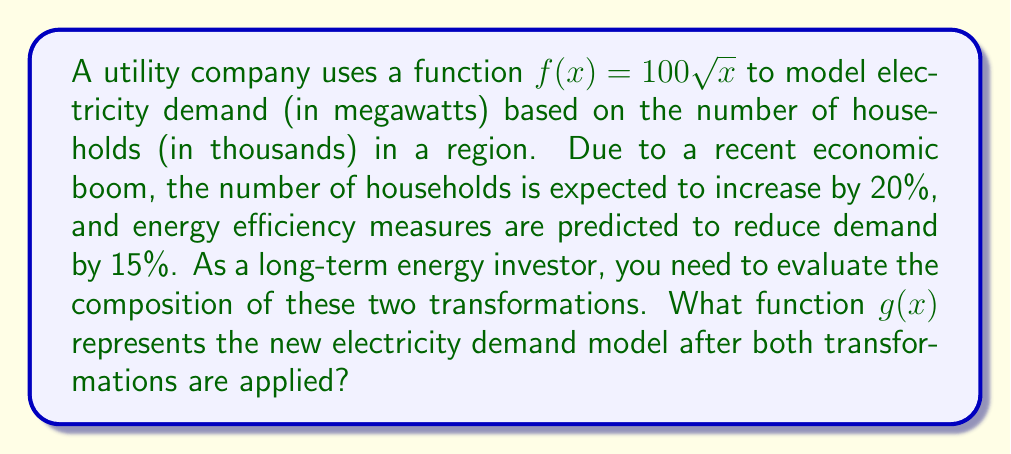Help me with this question. Let's approach this step-by-step:

1) First, we need to understand the two transformations:
   a) 20% increase in households: This is a horizontal compression by a factor of $\frac{1}{1.2}$
   b) 15% decrease in demand: This is a vertical compression by a factor of 0.85

2) Let's apply these transformations one at a time:

   a) For the horizontal compression:
      $f_1(x) = f(1.2x) = 100\sqrt{1.2x}$

   b) Now, for the vertical compression:
      $g(x) = 0.85f_1(x) = 0.85(100\sqrt{1.2x})$

3) Simplify:
   $g(x) = 85\sqrt{1.2x}$

4) We can further simplify by taking the constant under the square root:
   $g(x) = 85\sqrt{1.2}\sqrt{x}$

5) Calculate $\sqrt{1.2}$:
   $\sqrt{1.2} \approx 1.0954$

6) Therefore, our final function is:
   $g(x) = 85(1.0954)\sqrt{x} \approx 93.109\sqrt{x}$

This new function represents the electricity demand (in megawatts) based on the number of households (in thousands) after accounting for both the increase in households and the decrease in energy demand.
Answer: $g(x) \approx 93.109\sqrt{x}$ 